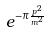Convert formula to latex. <formula><loc_0><loc_0><loc_500><loc_500>e ^ { - \pi \frac { p ^ { 2 } } { m ^ { 2 } } }</formula> 